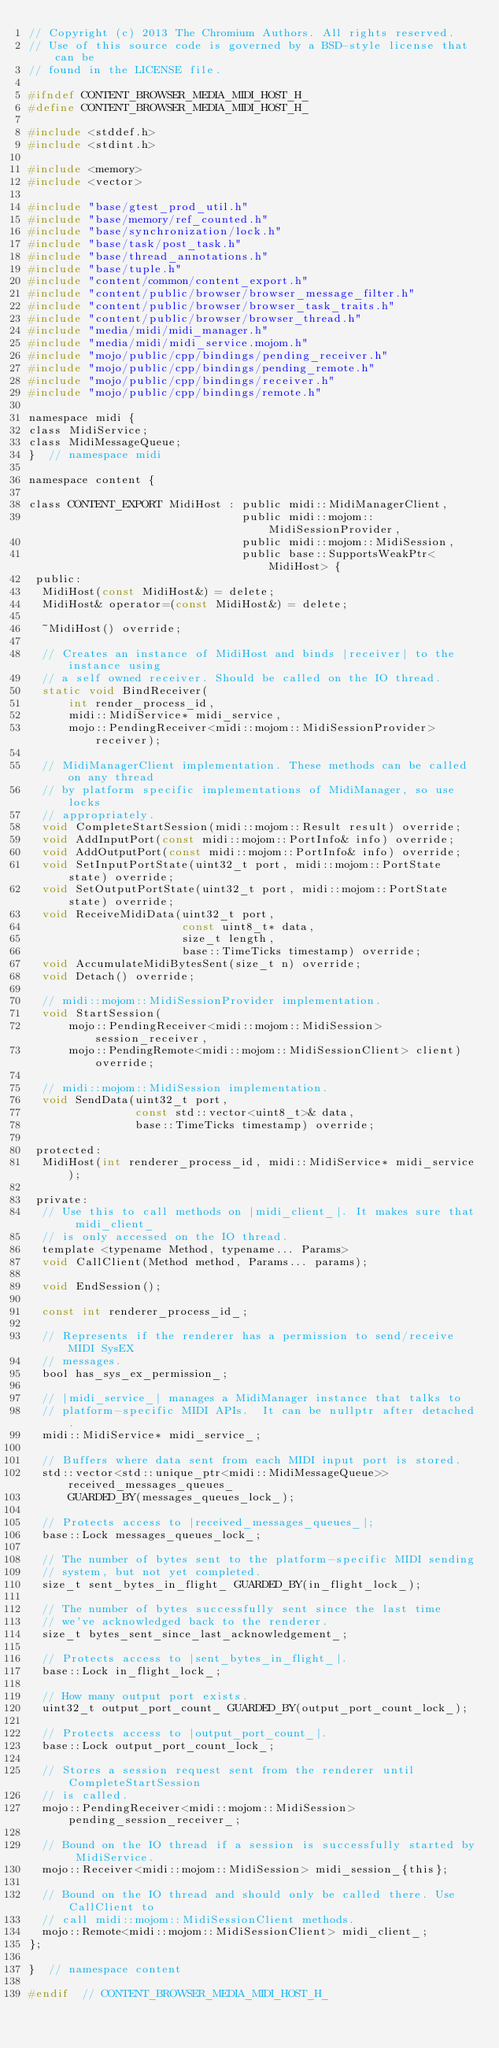Convert code to text. <code><loc_0><loc_0><loc_500><loc_500><_C_>// Copyright (c) 2013 The Chromium Authors. All rights reserved.
// Use of this source code is governed by a BSD-style license that can be
// found in the LICENSE file.

#ifndef CONTENT_BROWSER_MEDIA_MIDI_HOST_H_
#define CONTENT_BROWSER_MEDIA_MIDI_HOST_H_

#include <stddef.h>
#include <stdint.h>

#include <memory>
#include <vector>

#include "base/gtest_prod_util.h"
#include "base/memory/ref_counted.h"
#include "base/synchronization/lock.h"
#include "base/task/post_task.h"
#include "base/thread_annotations.h"
#include "base/tuple.h"
#include "content/common/content_export.h"
#include "content/public/browser/browser_message_filter.h"
#include "content/public/browser/browser_task_traits.h"
#include "content/public/browser/browser_thread.h"
#include "media/midi/midi_manager.h"
#include "media/midi/midi_service.mojom.h"
#include "mojo/public/cpp/bindings/pending_receiver.h"
#include "mojo/public/cpp/bindings/pending_remote.h"
#include "mojo/public/cpp/bindings/receiver.h"
#include "mojo/public/cpp/bindings/remote.h"

namespace midi {
class MidiService;
class MidiMessageQueue;
}  // namespace midi

namespace content {

class CONTENT_EXPORT MidiHost : public midi::MidiManagerClient,
                                public midi::mojom::MidiSessionProvider,
                                public midi::mojom::MidiSession,
                                public base::SupportsWeakPtr<MidiHost> {
 public:
  MidiHost(const MidiHost&) = delete;
  MidiHost& operator=(const MidiHost&) = delete;

  ~MidiHost() override;

  // Creates an instance of MidiHost and binds |receiver| to the instance using
  // a self owned receiver. Should be called on the IO thread.
  static void BindReceiver(
      int render_process_id,
      midi::MidiService* midi_service,
      mojo::PendingReceiver<midi::mojom::MidiSessionProvider> receiver);

  // MidiManagerClient implementation. These methods can be called on any thread
  // by platform specific implementations of MidiManager, so use locks
  // appropriately.
  void CompleteStartSession(midi::mojom::Result result) override;
  void AddInputPort(const midi::mojom::PortInfo& info) override;
  void AddOutputPort(const midi::mojom::PortInfo& info) override;
  void SetInputPortState(uint32_t port, midi::mojom::PortState state) override;
  void SetOutputPortState(uint32_t port, midi::mojom::PortState state) override;
  void ReceiveMidiData(uint32_t port,
                       const uint8_t* data,
                       size_t length,
                       base::TimeTicks timestamp) override;
  void AccumulateMidiBytesSent(size_t n) override;
  void Detach() override;

  // midi::mojom::MidiSessionProvider implementation.
  void StartSession(
      mojo::PendingReceiver<midi::mojom::MidiSession> session_receiver,
      mojo::PendingRemote<midi::mojom::MidiSessionClient> client) override;

  // midi::mojom::MidiSession implementation.
  void SendData(uint32_t port,
                const std::vector<uint8_t>& data,
                base::TimeTicks timestamp) override;

 protected:
  MidiHost(int renderer_process_id, midi::MidiService* midi_service);

 private:
  // Use this to call methods on |midi_client_|. It makes sure that midi_client_
  // is only accessed on the IO thread.
  template <typename Method, typename... Params>
  void CallClient(Method method, Params... params);

  void EndSession();

  const int renderer_process_id_;

  // Represents if the renderer has a permission to send/receive MIDI SysEX
  // messages.
  bool has_sys_ex_permission_;

  // |midi_service_| manages a MidiManager instance that talks to
  // platform-specific MIDI APIs.  It can be nullptr after detached.
  midi::MidiService* midi_service_;

  // Buffers where data sent from each MIDI input port is stored.
  std::vector<std::unique_ptr<midi::MidiMessageQueue>> received_messages_queues_
      GUARDED_BY(messages_queues_lock_);

  // Protects access to |received_messages_queues_|;
  base::Lock messages_queues_lock_;

  // The number of bytes sent to the platform-specific MIDI sending
  // system, but not yet completed.
  size_t sent_bytes_in_flight_ GUARDED_BY(in_flight_lock_);

  // The number of bytes successfully sent since the last time
  // we've acknowledged back to the renderer.
  size_t bytes_sent_since_last_acknowledgement_;

  // Protects access to |sent_bytes_in_flight_|.
  base::Lock in_flight_lock_;

  // How many output port exists.
  uint32_t output_port_count_ GUARDED_BY(output_port_count_lock_);

  // Protects access to |output_port_count_|.
  base::Lock output_port_count_lock_;

  // Stores a session request sent from the renderer until CompleteStartSession
  // is called.
  mojo::PendingReceiver<midi::mojom::MidiSession> pending_session_receiver_;

  // Bound on the IO thread if a session is successfully started by MidiService.
  mojo::Receiver<midi::mojom::MidiSession> midi_session_{this};

  // Bound on the IO thread and should only be called there. Use CallClient to
  // call midi::mojom::MidiSessionClient methods.
  mojo::Remote<midi::mojom::MidiSessionClient> midi_client_;
};

}  // namespace content

#endif  // CONTENT_BROWSER_MEDIA_MIDI_HOST_H_
</code> 